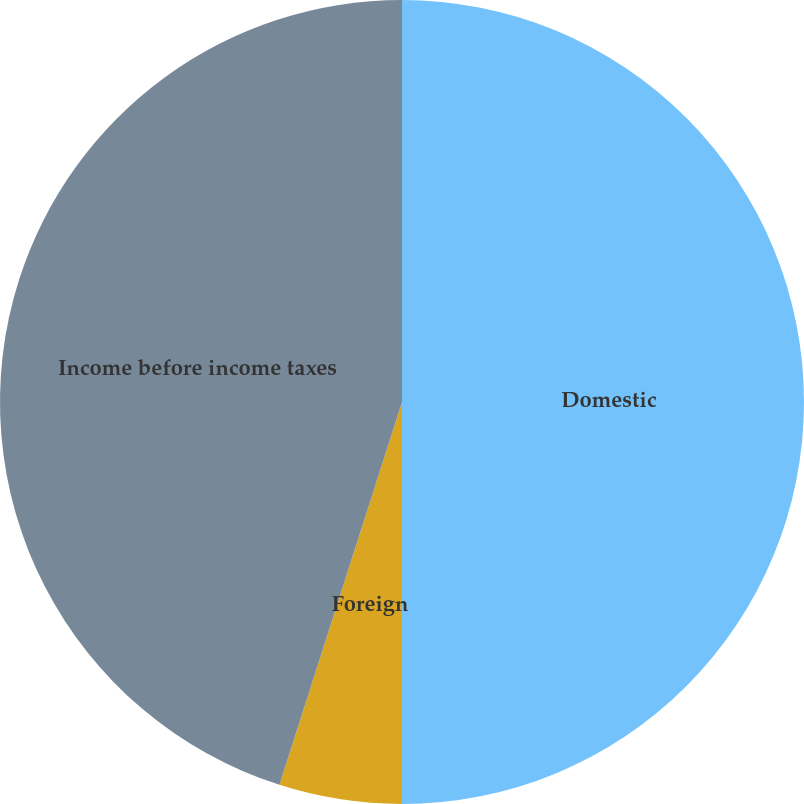<chart> <loc_0><loc_0><loc_500><loc_500><pie_chart><fcel>Domestic<fcel>Foreign<fcel>Income before income taxes<nl><fcel>50.0%<fcel>4.93%<fcel>45.07%<nl></chart> 